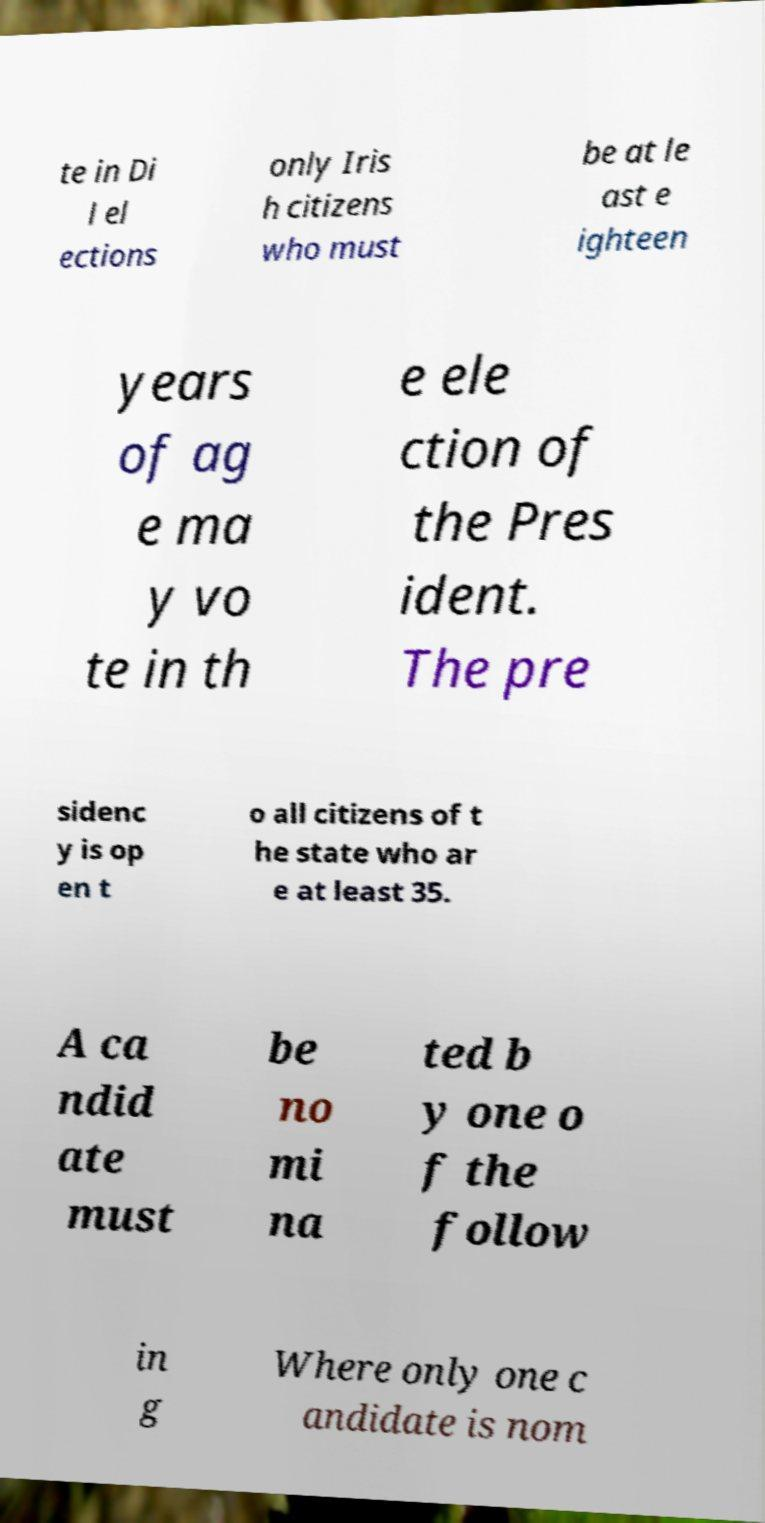For documentation purposes, I need the text within this image transcribed. Could you provide that? te in Di l el ections only Iris h citizens who must be at le ast e ighteen years of ag e ma y vo te in th e ele ction of the Pres ident. The pre sidenc y is op en t o all citizens of t he state who ar e at least 35. A ca ndid ate must be no mi na ted b y one o f the follow in g Where only one c andidate is nom 